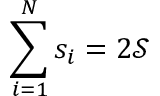Convert formula to latex. <formula><loc_0><loc_0><loc_500><loc_500>\sum _ { i = 1 } ^ { N } s _ { i } = 2 \mathcal { S }</formula> 